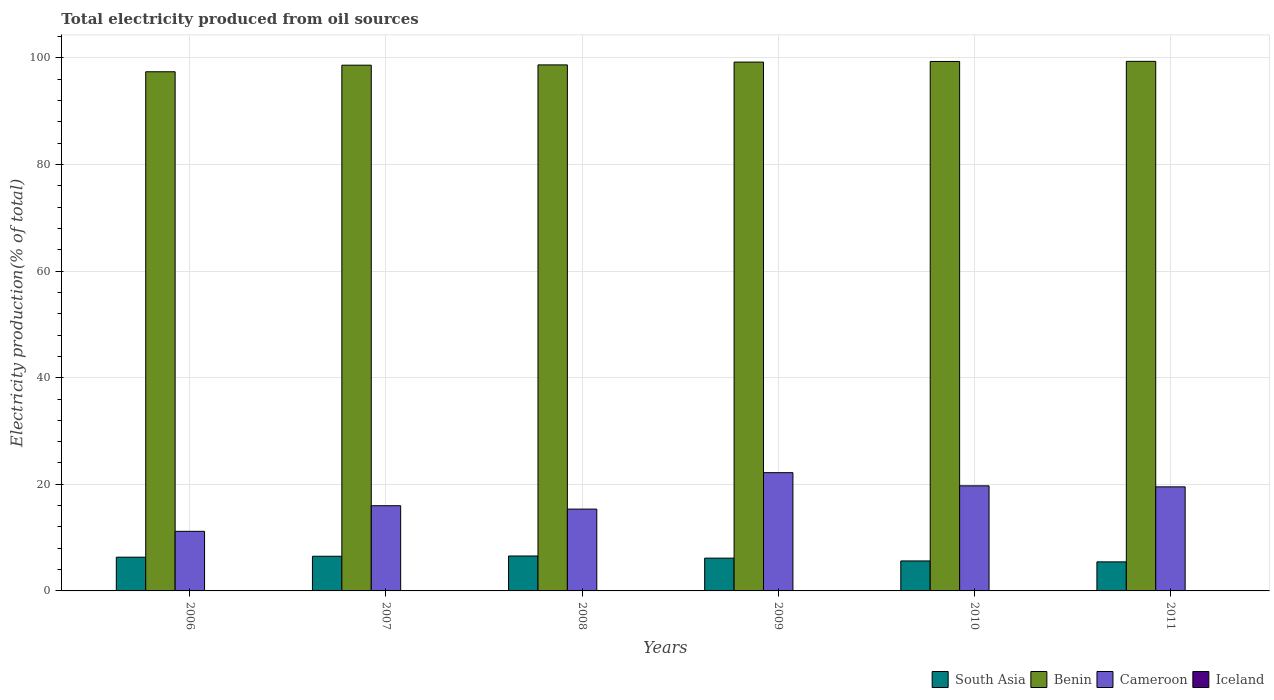How many different coloured bars are there?
Your response must be concise. 4. How many bars are there on the 6th tick from the left?
Make the answer very short. 4. What is the total electricity produced in Cameroon in 2008?
Your response must be concise. 15.35. Across all years, what is the maximum total electricity produced in Cameroon?
Give a very brief answer. 22.19. Across all years, what is the minimum total electricity produced in Cameroon?
Keep it short and to the point. 11.18. What is the total total electricity produced in Benin in the graph?
Offer a very short reply. 592.64. What is the difference between the total electricity produced in Benin in 2010 and that in 2011?
Your answer should be compact. -0.02. What is the difference between the total electricity produced in Benin in 2008 and the total electricity produced in Cameroon in 2007?
Offer a very short reply. 82.71. What is the average total electricity produced in Benin per year?
Make the answer very short. 98.77. In the year 2011, what is the difference between the total electricity produced in Iceland and total electricity produced in Cameroon?
Offer a very short reply. -19.51. What is the ratio of the total electricity produced in South Asia in 2007 to that in 2011?
Ensure brevity in your answer.  1.19. Is the total electricity produced in Iceland in 2006 less than that in 2007?
Provide a short and direct response. No. What is the difference between the highest and the second highest total electricity produced in Cameroon?
Give a very brief answer. 2.47. What is the difference between the highest and the lowest total electricity produced in Iceland?
Provide a succinct answer. 0.03. Is the sum of the total electricity produced in Cameroon in 2007 and 2010 greater than the maximum total electricity produced in Iceland across all years?
Offer a terse response. Yes. What does the 3rd bar from the left in 2008 represents?
Your answer should be very brief. Cameroon. Is it the case that in every year, the sum of the total electricity produced in South Asia and total electricity produced in Cameroon is greater than the total electricity produced in Benin?
Keep it short and to the point. No. Are all the bars in the graph horizontal?
Offer a very short reply. No. What is the difference between two consecutive major ticks on the Y-axis?
Your response must be concise. 20. Where does the legend appear in the graph?
Offer a very short reply. Bottom right. How are the legend labels stacked?
Your answer should be compact. Horizontal. What is the title of the graph?
Offer a terse response. Total electricity produced from oil sources. What is the label or title of the X-axis?
Keep it short and to the point. Years. What is the Electricity production(% of total) of South Asia in 2006?
Your answer should be compact. 6.33. What is the Electricity production(% of total) of Benin in 2006?
Your answer should be very brief. 97.4. What is the Electricity production(% of total) of Cameroon in 2006?
Give a very brief answer. 11.18. What is the Electricity production(% of total) in Iceland in 2006?
Ensure brevity in your answer.  0.04. What is the Electricity production(% of total) of South Asia in 2007?
Your answer should be compact. 6.5. What is the Electricity production(% of total) in Benin in 2007?
Ensure brevity in your answer.  98.64. What is the Electricity production(% of total) in Cameroon in 2007?
Keep it short and to the point. 15.98. What is the Electricity production(% of total) in Iceland in 2007?
Your response must be concise. 0.02. What is the Electricity production(% of total) in South Asia in 2008?
Your answer should be very brief. 6.55. What is the Electricity production(% of total) in Benin in 2008?
Provide a succinct answer. 98.69. What is the Electricity production(% of total) in Cameroon in 2008?
Offer a very short reply. 15.35. What is the Electricity production(% of total) of Iceland in 2008?
Your answer should be very brief. 0.01. What is the Electricity production(% of total) in South Asia in 2009?
Your answer should be very brief. 6.15. What is the Electricity production(% of total) in Benin in 2009?
Offer a very short reply. 99.22. What is the Electricity production(% of total) in Cameroon in 2009?
Your response must be concise. 22.19. What is the Electricity production(% of total) in Iceland in 2009?
Keep it short and to the point. 0.01. What is the Electricity production(% of total) of South Asia in 2010?
Your response must be concise. 5.63. What is the Electricity production(% of total) of Benin in 2010?
Offer a terse response. 99.33. What is the Electricity production(% of total) in Cameroon in 2010?
Keep it short and to the point. 19.72. What is the Electricity production(% of total) in Iceland in 2010?
Keep it short and to the point. 0.01. What is the Electricity production(% of total) of South Asia in 2011?
Give a very brief answer. 5.45. What is the Electricity production(% of total) of Benin in 2011?
Offer a very short reply. 99.35. What is the Electricity production(% of total) in Cameroon in 2011?
Keep it short and to the point. 19.53. What is the Electricity production(% of total) of Iceland in 2011?
Offer a terse response. 0.01. Across all years, what is the maximum Electricity production(% of total) in South Asia?
Give a very brief answer. 6.55. Across all years, what is the maximum Electricity production(% of total) of Benin?
Your answer should be very brief. 99.35. Across all years, what is the maximum Electricity production(% of total) in Cameroon?
Offer a terse response. 22.19. Across all years, what is the maximum Electricity production(% of total) of Iceland?
Your response must be concise. 0.04. Across all years, what is the minimum Electricity production(% of total) in South Asia?
Your answer should be very brief. 5.45. Across all years, what is the minimum Electricity production(% of total) in Benin?
Provide a short and direct response. 97.4. Across all years, what is the minimum Electricity production(% of total) of Cameroon?
Provide a short and direct response. 11.18. Across all years, what is the minimum Electricity production(% of total) of Iceland?
Your answer should be very brief. 0.01. What is the total Electricity production(% of total) of South Asia in the graph?
Your response must be concise. 36.62. What is the total Electricity production(% of total) in Benin in the graph?
Your response must be concise. 592.64. What is the total Electricity production(% of total) of Cameroon in the graph?
Offer a very short reply. 103.94. What is the total Electricity production(% of total) in Iceland in the graph?
Keep it short and to the point. 0.1. What is the difference between the Electricity production(% of total) of South Asia in 2006 and that in 2007?
Keep it short and to the point. -0.17. What is the difference between the Electricity production(% of total) of Benin in 2006 and that in 2007?
Offer a very short reply. -1.23. What is the difference between the Electricity production(% of total) of Cameroon in 2006 and that in 2007?
Offer a terse response. -4.8. What is the difference between the Electricity production(% of total) in Iceland in 2006 and that in 2007?
Offer a terse response. 0.02. What is the difference between the Electricity production(% of total) in South Asia in 2006 and that in 2008?
Give a very brief answer. -0.22. What is the difference between the Electricity production(% of total) of Benin in 2006 and that in 2008?
Provide a short and direct response. -1.29. What is the difference between the Electricity production(% of total) of Cameroon in 2006 and that in 2008?
Your answer should be very brief. -4.17. What is the difference between the Electricity production(% of total) of Iceland in 2006 and that in 2008?
Your answer should be very brief. 0.03. What is the difference between the Electricity production(% of total) of South Asia in 2006 and that in 2009?
Keep it short and to the point. 0.18. What is the difference between the Electricity production(% of total) in Benin in 2006 and that in 2009?
Your response must be concise. -1.82. What is the difference between the Electricity production(% of total) in Cameroon in 2006 and that in 2009?
Your answer should be compact. -11. What is the difference between the Electricity production(% of total) in Iceland in 2006 and that in 2009?
Keep it short and to the point. 0.03. What is the difference between the Electricity production(% of total) in South Asia in 2006 and that in 2010?
Provide a short and direct response. 0.7. What is the difference between the Electricity production(% of total) of Benin in 2006 and that in 2010?
Give a very brief answer. -1.93. What is the difference between the Electricity production(% of total) of Cameroon in 2006 and that in 2010?
Your answer should be very brief. -8.53. What is the difference between the Electricity production(% of total) in Iceland in 2006 and that in 2010?
Your answer should be very brief. 0.03. What is the difference between the Electricity production(% of total) in South Asia in 2006 and that in 2011?
Give a very brief answer. 0.88. What is the difference between the Electricity production(% of total) in Benin in 2006 and that in 2011?
Offer a very short reply. -1.95. What is the difference between the Electricity production(% of total) of Cameroon in 2006 and that in 2011?
Provide a succinct answer. -8.34. What is the difference between the Electricity production(% of total) in Iceland in 2006 and that in 2011?
Give a very brief answer. 0.03. What is the difference between the Electricity production(% of total) in South Asia in 2007 and that in 2008?
Provide a short and direct response. -0.05. What is the difference between the Electricity production(% of total) of Benin in 2007 and that in 2008?
Your response must be concise. -0.05. What is the difference between the Electricity production(% of total) in Cameroon in 2007 and that in 2008?
Your answer should be very brief. 0.63. What is the difference between the Electricity production(% of total) in Iceland in 2007 and that in 2008?
Ensure brevity in your answer.  0. What is the difference between the Electricity production(% of total) of South Asia in 2007 and that in 2009?
Offer a very short reply. 0.35. What is the difference between the Electricity production(% of total) in Benin in 2007 and that in 2009?
Ensure brevity in your answer.  -0.58. What is the difference between the Electricity production(% of total) in Cameroon in 2007 and that in 2009?
Your answer should be very brief. -6.2. What is the difference between the Electricity production(% of total) of Iceland in 2007 and that in 2009?
Provide a succinct answer. 0. What is the difference between the Electricity production(% of total) in South Asia in 2007 and that in 2010?
Make the answer very short. 0.88. What is the difference between the Electricity production(% of total) in Benin in 2007 and that in 2010?
Your answer should be compact. -0.7. What is the difference between the Electricity production(% of total) of Cameroon in 2007 and that in 2010?
Make the answer very short. -3.73. What is the difference between the Electricity production(% of total) in Iceland in 2007 and that in 2010?
Your response must be concise. 0.01. What is the difference between the Electricity production(% of total) in South Asia in 2007 and that in 2011?
Provide a short and direct response. 1.05. What is the difference between the Electricity production(% of total) of Benin in 2007 and that in 2011?
Your answer should be very brief. -0.72. What is the difference between the Electricity production(% of total) of Cameroon in 2007 and that in 2011?
Make the answer very short. -3.54. What is the difference between the Electricity production(% of total) in Iceland in 2007 and that in 2011?
Your response must be concise. 0.01. What is the difference between the Electricity production(% of total) in South Asia in 2008 and that in 2009?
Ensure brevity in your answer.  0.4. What is the difference between the Electricity production(% of total) of Benin in 2008 and that in 2009?
Provide a short and direct response. -0.53. What is the difference between the Electricity production(% of total) of Cameroon in 2008 and that in 2009?
Your response must be concise. -6.84. What is the difference between the Electricity production(% of total) in South Asia in 2008 and that in 2010?
Make the answer very short. 0.93. What is the difference between the Electricity production(% of total) of Benin in 2008 and that in 2010?
Your response must be concise. -0.64. What is the difference between the Electricity production(% of total) in Cameroon in 2008 and that in 2010?
Your answer should be compact. -4.37. What is the difference between the Electricity production(% of total) in Iceland in 2008 and that in 2010?
Your answer should be very brief. 0. What is the difference between the Electricity production(% of total) in South Asia in 2008 and that in 2011?
Ensure brevity in your answer.  1.1. What is the difference between the Electricity production(% of total) in Benin in 2008 and that in 2011?
Your response must be concise. -0.66. What is the difference between the Electricity production(% of total) in Cameroon in 2008 and that in 2011?
Provide a short and direct response. -4.18. What is the difference between the Electricity production(% of total) in South Asia in 2009 and that in 2010?
Your answer should be compact. 0.53. What is the difference between the Electricity production(% of total) in Benin in 2009 and that in 2010?
Your response must be concise. -0.11. What is the difference between the Electricity production(% of total) in Cameroon in 2009 and that in 2010?
Provide a succinct answer. 2.47. What is the difference between the Electricity production(% of total) in South Asia in 2009 and that in 2011?
Give a very brief answer. 0.7. What is the difference between the Electricity production(% of total) of Benin in 2009 and that in 2011?
Provide a succinct answer. -0.14. What is the difference between the Electricity production(% of total) of Cameroon in 2009 and that in 2011?
Offer a very short reply. 2.66. What is the difference between the Electricity production(% of total) in Iceland in 2009 and that in 2011?
Give a very brief answer. 0. What is the difference between the Electricity production(% of total) in South Asia in 2010 and that in 2011?
Keep it short and to the point. 0.17. What is the difference between the Electricity production(% of total) of Benin in 2010 and that in 2011?
Ensure brevity in your answer.  -0.02. What is the difference between the Electricity production(% of total) in Cameroon in 2010 and that in 2011?
Provide a short and direct response. 0.19. What is the difference between the Electricity production(% of total) in South Asia in 2006 and the Electricity production(% of total) in Benin in 2007?
Give a very brief answer. -92.31. What is the difference between the Electricity production(% of total) in South Asia in 2006 and the Electricity production(% of total) in Cameroon in 2007?
Your response must be concise. -9.65. What is the difference between the Electricity production(% of total) in South Asia in 2006 and the Electricity production(% of total) in Iceland in 2007?
Provide a short and direct response. 6.31. What is the difference between the Electricity production(% of total) of Benin in 2006 and the Electricity production(% of total) of Cameroon in 2007?
Provide a succinct answer. 81.42. What is the difference between the Electricity production(% of total) of Benin in 2006 and the Electricity production(% of total) of Iceland in 2007?
Offer a terse response. 97.39. What is the difference between the Electricity production(% of total) of Cameroon in 2006 and the Electricity production(% of total) of Iceland in 2007?
Provide a short and direct response. 11.17. What is the difference between the Electricity production(% of total) of South Asia in 2006 and the Electricity production(% of total) of Benin in 2008?
Offer a very short reply. -92.36. What is the difference between the Electricity production(% of total) in South Asia in 2006 and the Electricity production(% of total) in Cameroon in 2008?
Your answer should be very brief. -9.02. What is the difference between the Electricity production(% of total) of South Asia in 2006 and the Electricity production(% of total) of Iceland in 2008?
Ensure brevity in your answer.  6.32. What is the difference between the Electricity production(% of total) in Benin in 2006 and the Electricity production(% of total) in Cameroon in 2008?
Give a very brief answer. 82.05. What is the difference between the Electricity production(% of total) in Benin in 2006 and the Electricity production(% of total) in Iceland in 2008?
Give a very brief answer. 97.39. What is the difference between the Electricity production(% of total) of Cameroon in 2006 and the Electricity production(% of total) of Iceland in 2008?
Keep it short and to the point. 11.17. What is the difference between the Electricity production(% of total) in South Asia in 2006 and the Electricity production(% of total) in Benin in 2009?
Make the answer very short. -92.89. What is the difference between the Electricity production(% of total) in South Asia in 2006 and the Electricity production(% of total) in Cameroon in 2009?
Offer a very short reply. -15.86. What is the difference between the Electricity production(% of total) of South Asia in 2006 and the Electricity production(% of total) of Iceland in 2009?
Provide a succinct answer. 6.32. What is the difference between the Electricity production(% of total) of Benin in 2006 and the Electricity production(% of total) of Cameroon in 2009?
Give a very brief answer. 75.22. What is the difference between the Electricity production(% of total) of Benin in 2006 and the Electricity production(% of total) of Iceland in 2009?
Your answer should be compact. 97.39. What is the difference between the Electricity production(% of total) of Cameroon in 2006 and the Electricity production(% of total) of Iceland in 2009?
Provide a short and direct response. 11.17. What is the difference between the Electricity production(% of total) of South Asia in 2006 and the Electricity production(% of total) of Benin in 2010?
Your response must be concise. -93. What is the difference between the Electricity production(% of total) in South Asia in 2006 and the Electricity production(% of total) in Cameroon in 2010?
Your response must be concise. -13.38. What is the difference between the Electricity production(% of total) in South Asia in 2006 and the Electricity production(% of total) in Iceland in 2010?
Ensure brevity in your answer.  6.32. What is the difference between the Electricity production(% of total) of Benin in 2006 and the Electricity production(% of total) of Cameroon in 2010?
Make the answer very short. 77.69. What is the difference between the Electricity production(% of total) in Benin in 2006 and the Electricity production(% of total) in Iceland in 2010?
Offer a terse response. 97.39. What is the difference between the Electricity production(% of total) in Cameroon in 2006 and the Electricity production(% of total) in Iceland in 2010?
Provide a succinct answer. 11.17. What is the difference between the Electricity production(% of total) of South Asia in 2006 and the Electricity production(% of total) of Benin in 2011?
Ensure brevity in your answer.  -93.02. What is the difference between the Electricity production(% of total) in South Asia in 2006 and the Electricity production(% of total) in Cameroon in 2011?
Keep it short and to the point. -13.2. What is the difference between the Electricity production(% of total) of South Asia in 2006 and the Electricity production(% of total) of Iceland in 2011?
Provide a short and direct response. 6.32. What is the difference between the Electricity production(% of total) in Benin in 2006 and the Electricity production(% of total) in Cameroon in 2011?
Your response must be concise. 77.88. What is the difference between the Electricity production(% of total) in Benin in 2006 and the Electricity production(% of total) in Iceland in 2011?
Provide a succinct answer. 97.39. What is the difference between the Electricity production(% of total) of Cameroon in 2006 and the Electricity production(% of total) of Iceland in 2011?
Your answer should be compact. 11.17. What is the difference between the Electricity production(% of total) of South Asia in 2007 and the Electricity production(% of total) of Benin in 2008?
Your answer should be very brief. -92.19. What is the difference between the Electricity production(% of total) in South Asia in 2007 and the Electricity production(% of total) in Cameroon in 2008?
Provide a short and direct response. -8.85. What is the difference between the Electricity production(% of total) of South Asia in 2007 and the Electricity production(% of total) of Iceland in 2008?
Ensure brevity in your answer.  6.49. What is the difference between the Electricity production(% of total) in Benin in 2007 and the Electricity production(% of total) in Cameroon in 2008?
Your answer should be compact. 83.29. What is the difference between the Electricity production(% of total) in Benin in 2007 and the Electricity production(% of total) in Iceland in 2008?
Provide a short and direct response. 98.62. What is the difference between the Electricity production(% of total) of Cameroon in 2007 and the Electricity production(% of total) of Iceland in 2008?
Offer a terse response. 15.97. What is the difference between the Electricity production(% of total) of South Asia in 2007 and the Electricity production(% of total) of Benin in 2009?
Offer a terse response. -92.72. What is the difference between the Electricity production(% of total) in South Asia in 2007 and the Electricity production(% of total) in Cameroon in 2009?
Ensure brevity in your answer.  -15.68. What is the difference between the Electricity production(% of total) of South Asia in 2007 and the Electricity production(% of total) of Iceland in 2009?
Offer a very short reply. 6.49. What is the difference between the Electricity production(% of total) of Benin in 2007 and the Electricity production(% of total) of Cameroon in 2009?
Keep it short and to the point. 76.45. What is the difference between the Electricity production(% of total) of Benin in 2007 and the Electricity production(% of total) of Iceland in 2009?
Offer a very short reply. 98.62. What is the difference between the Electricity production(% of total) of Cameroon in 2007 and the Electricity production(% of total) of Iceland in 2009?
Your response must be concise. 15.97. What is the difference between the Electricity production(% of total) of South Asia in 2007 and the Electricity production(% of total) of Benin in 2010?
Provide a short and direct response. -92.83. What is the difference between the Electricity production(% of total) of South Asia in 2007 and the Electricity production(% of total) of Cameroon in 2010?
Offer a very short reply. -13.21. What is the difference between the Electricity production(% of total) in South Asia in 2007 and the Electricity production(% of total) in Iceland in 2010?
Ensure brevity in your answer.  6.49. What is the difference between the Electricity production(% of total) in Benin in 2007 and the Electricity production(% of total) in Cameroon in 2010?
Provide a short and direct response. 78.92. What is the difference between the Electricity production(% of total) of Benin in 2007 and the Electricity production(% of total) of Iceland in 2010?
Offer a very short reply. 98.62. What is the difference between the Electricity production(% of total) in Cameroon in 2007 and the Electricity production(% of total) in Iceland in 2010?
Your answer should be compact. 15.97. What is the difference between the Electricity production(% of total) of South Asia in 2007 and the Electricity production(% of total) of Benin in 2011?
Give a very brief answer. -92.85. What is the difference between the Electricity production(% of total) of South Asia in 2007 and the Electricity production(% of total) of Cameroon in 2011?
Offer a very short reply. -13.02. What is the difference between the Electricity production(% of total) of South Asia in 2007 and the Electricity production(% of total) of Iceland in 2011?
Offer a very short reply. 6.49. What is the difference between the Electricity production(% of total) in Benin in 2007 and the Electricity production(% of total) in Cameroon in 2011?
Your answer should be compact. 79.11. What is the difference between the Electricity production(% of total) of Benin in 2007 and the Electricity production(% of total) of Iceland in 2011?
Provide a succinct answer. 98.62. What is the difference between the Electricity production(% of total) of Cameroon in 2007 and the Electricity production(% of total) of Iceland in 2011?
Offer a terse response. 15.97. What is the difference between the Electricity production(% of total) of South Asia in 2008 and the Electricity production(% of total) of Benin in 2009?
Ensure brevity in your answer.  -92.66. What is the difference between the Electricity production(% of total) of South Asia in 2008 and the Electricity production(% of total) of Cameroon in 2009?
Make the answer very short. -15.63. What is the difference between the Electricity production(% of total) of South Asia in 2008 and the Electricity production(% of total) of Iceland in 2009?
Make the answer very short. 6.54. What is the difference between the Electricity production(% of total) in Benin in 2008 and the Electricity production(% of total) in Cameroon in 2009?
Make the answer very short. 76.5. What is the difference between the Electricity production(% of total) in Benin in 2008 and the Electricity production(% of total) in Iceland in 2009?
Your response must be concise. 98.68. What is the difference between the Electricity production(% of total) in Cameroon in 2008 and the Electricity production(% of total) in Iceland in 2009?
Your response must be concise. 15.34. What is the difference between the Electricity production(% of total) of South Asia in 2008 and the Electricity production(% of total) of Benin in 2010?
Keep it short and to the point. -92.78. What is the difference between the Electricity production(% of total) in South Asia in 2008 and the Electricity production(% of total) in Cameroon in 2010?
Your answer should be compact. -13.16. What is the difference between the Electricity production(% of total) of South Asia in 2008 and the Electricity production(% of total) of Iceland in 2010?
Offer a terse response. 6.54. What is the difference between the Electricity production(% of total) in Benin in 2008 and the Electricity production(% of total) in Cameroon in 2010?
Your answer should be compact. 78.97. What is the difference between the Electricity production(% of total) of Benin in 2008 and the Electricity production(% of total) of Iceland in 2010?
Your answer should be very brief. 98.68. What is the difference between the Electricity production(% of total) in Cameroon in 2008 and the Electricity production(% of total) in Iceland in 2010?
Your response must be concise. 15.34. What is the difference between the Electricity production(% of total) of South Asia in 2008 and the Electricity production(% of total) of Benin in 2011?
Your answer should be compact. -92.8. What is the difference between the Electricity production(% of total) of South Asia in 2008 and the Electricity production(% of total) of Cameroon in 2011?
Keep it short and to the point. -12.97. What is the difference between the Electricity production(% of total) in South Asia in 2008 and the Electricity production(% of total) in Iceland in 2011?
Your answer should be compact. 6.54. What is the difference between the Electricity production(% of total) in Benin in 2008 and the Electricity production(% of total) in Cameroon in 2011?
Make the answer very short. 79.16. What is the difference between the Electricity production(% of total) of Benin in 2008 and the Electricity production(% of total) of Iceland in 2011?
Offer a very short reply. 98.68. What is the difference between the Electricity production(% of total) in Cameroon in 2008 and the Electricity production(% of total) in Iceland in 2011?
Give a very brief answer. 15.34. What is the difference between the Electricity production(% of total) in South Asia in 2009 and the Electricity production(% of total) in Benin in 2010?
Offer a terse response. -93.18. What is the difference between the Electricity production(% of total) in South Asia in 2009 and the Electricity production(% of total) in Cameroon in 2010?
Make the answer very short. -13.56. What is the difference between the Electricity production(% of total) in South Asia in 2009 and the Electricity production(% of total) in Iceland in 2010?
Provide a succinct answer. 6.14. What is the difference between the Electricity production(% of total) in Benin in 2009 and the Electricity production(% of total) in Cameroon in 2010?
Provide a succinct answer. 79.5. What is the difference between the Electricity production(% of total) in Benin in 2009 and the Electricity production(% of total) in Iceland in 2010?
Ensure brevity in your answer.  99.21. What is the difference between the Electricity production(% of total) of Cameroon in 2009 and the Electricity production(% of total) of Iceland in 2010?
Offer a terse response. 22.17. What is the difference between the Electricity production(% of total) in South Asia in 2009 and the Electricity production(% of total) in Benin in 2011?
Ensure brevity in your answer.  -93.2. What is the difference between the Electricity production(% of total) of South Asia in 2009 and the Electricity production(% of total) of Cameroon in 2011?
Provide a short and direct response. -13.37. What is the difference between the Electricity production(% of total) in South Asia in 2009 and the Electricity production(% of total) in Iceland in 2011?
Your answer should be very brief. 6.14. What is the difference between the Electricity production(% of total) in Benin in 2009 and the Electricity production(% of total) in Cameroon in 2011?
Provide a short and direct response. 79.69. What is the difference between the Electricity production(% of total) in Benin in 2009 and the Electricity production(% of total) in Iceland in 2011?
Ensure brevity in your answer.  99.21. What is the difference between the Electricity production(% of total) in Cameroon in 2009 and the Electricity production(% of total) in Iceland in 2011?
Give a very brief answer. 22.17. What is the difference between the Electricity production(% of total) of South Asia in 2010 and the Electricity production(% of total) of Benin in 2011?
Your answer should be compact. -93.73. What is the difference between the Electricity production(% of total) in South Asia in 2010 and the Electricity production(% of total) in Iceland in 2011?
Your response must be concise. 5.61. What is the difference between the Electricity production(% of total) of Benin in 2010 and the Electricity production(% of total) of Cameroon in 2011?
Provide a succinct answer. 79.81. What is the difference between the Electricity production(% of total) in Benin in 2010 and the Electricity production(% of total) in Iceland in 2011?
Provide a succinct answer. 99.32. What is the difference between the Electricity production(% of total) of Cameroon in 2010 and the Electricity production(% of total) of Iceland in 2011?
Your answer should be very brief. 19.7. What is the average Electricity production(% of total) of South Asia per year?
Your answer should be compact. 6.1. What is the average Electricity production(% of total) in Benin per year?
Make the answer very short. 98.77. What is the average Electricity production(% of total) in Cameroon per year?
Make the answer very short. 17.32. What is the average Electricity production(% of total) in Iceland per year?
Give a very brief answer. 0.02. In the year 2006, what is the difference between the Electricity production(% of total) in South Asia and Electricity production(% of total) in Benin?
Offer a very short reply. -91.07. In the year 2006, what is the difference between the Electricity production(% of total) in South Asia and Electricity production(% of total) in Cameroon?
Keep it short and to the point. -4.85. In the year 2006, what is the difference between the Electricity production(% of total) in South Asia and Electricity production(% of total) in Iceland?
Ensure brevity in your answer.  6.29. In the year 2006, what is the difference between the Electricity production(% of total) of Benin and Electricity production(% of total) of Cameroon?
Offer a very short reply. 86.22. In the year 2006, what is the difference between the Electricity production(% of total) of Benin and Electricity production(% of total) of Iceland?
Your answer should be very brief. 97.36. In the year 2006, what is the difference between the Electricity production(% of total) in Cameroon and Electricity production(% of total) in Iceland?
Your response must be concise. 11.14. In the year 2007, what is the difference between the Electricity production(% of total) of South Asia and Electricity production(% of total) of Benin?
Provide a succinct answer. -92.13. In the year 2007, what is the difference between the Electricity production(% of total) of South Asia and Electricity production(% of total) of Cameroon?
Give a very brief answer. -9.48. In the year 2007, what is the difference between the Electricity production(% of total) in South Asia and Electricity production(% of total) in Iceland?
Offer a very short reply. 6.49. In the year 2007, what is the difference between the Electricity production(% of total) in Benin and Electricity production(% of total) in Cameroon?
Ensure brevity in your answer.  82.65. In the year 2007, what is the difference between the Electricity production(% of total) of Benin and Electricity production(% of total) of Iceland?
Offer a terse response. 98.62. In the year 2007, what is the difference between the Electricity production(% of total) in Cameroon and Electricity production(% of total) in Iceland?
Make the answer very short. 15.97. In the year 2008, what is the difference between the Electricity production(% of total) in South Asia and Electricity production(% of total) in Benin?
Provide a succinct answer. -92.14. In the year 2008, what is the difference between the Electricity production(% of total) in South Asia and Electricity production(% of total) in Cameroon?
Your answer should be very brief. -8.8. In the year 2008, what is the difference between the Electricity production(% of total) in South Asia and Electricity production(% of total) in Iceland?
Keep it short and to the point. 6.54. In the year 2008, what is the difference between the Electricity production(% of total) of Benin and Electricity production(% of total) of Cameroon?
Give a very brief answer. 83.34. In the year 2008, what is the difference between the Electricity production(% of total) of Benin and Electricity production(% of total) of Iceland?
Keep it short and to the point. 98.68. In the year 2008, what is the difference between the Electricity production(% of total) in Cameroon and Electricity production(% of total) in Iceland?
Offer a terse response. 15.34. In the year 2009, what is the difference between the Electricity production(% of total) of South Asia and Electricity production(% of total) of Benin?
Your answer should be very brief. -93.07. In the year 2009, what is the difference between the Electricity production(% of total) in South Asia and Electricity production(% of total) in Cameroon?
Provide a short and direct response. -16.03. In the year 2009, what is the difference between the Electricity production(% of total) of South Asia and Electricity production(% of total) of Iceland?
Give a very brief answer. 6.14. In the year 2009, what is the difference between the Electricity production(% of total) of Benin and Electricity production(% of total) of Cameroon?
Your answer should be compact. 77.03. In the year 2009, what is the difference between the Electricity production(% of total) of Benin and Electricity production(% of total) of Iceland?
Offer a terse response. 99.21. In the year 2009, what is the difference between the Electricity production(% of total) of Cameroon and Electricity production(% of total) of Iceland?
Offer a terse response. 22.17. In the year 2010, what is the difference between the Electricity production(% of total) in South Asia and Electricity production(% of total) in Benin?
Keep it short and to the point. -93.71. In the year 2010, what is the difference between the Electricity production(% of total) of South Asia and Electricity production(% of total) of Cameroon?
Offer a very short reply. -14.09. In the year 2010, what is the difference between the Electricity production(% of total) in South Asia and Electricity production(% of total) in Iceland?
Offer a terse response. 5.61. In the year 2010, what is the difference between the Electricity production(% of total) in Benin and Electricity production(% of total) in Cameroon?
Keep it short and to the point. 79.62. In the year 2010, what is the difference between the Electricity production(% of total) in Benin and Electricity production(% of total) in Iceland?
Offer a very short reply. 99.32. In the year 2010, what is the difference between the Electricity production(% of total) of Cameroon and Electricity production(% of total) of Iceland?
Make the answer very short. 19.7. In the year 2011, what is the difference between the Electricity production(% of total) in South Asia and Electricity production(% of total) in Benin?
Your answer should be very brief. -93.9. In the year 2011, what is the difference between the Electricity production(% of total) in South Asia and Electricity production(% of total) in Cameroon?
Keep it short and to the point. -14.07. In the year 2011, what is the difference between the Electricity production(% of total) of South Asia and Electricity production(% of total) of Iceland?
Your answer should be compact. 5.44. In the year 2011, what is the difference between the Electricity production(% of total) in Benin and Electricity production(% of total) in Cameroon?
Your answer should be very brief. 79.83. In the year 2011, what is the difference between the Electricity production(% of total) of Benin and Electricity production(% of total) of Iceland?
Provide a succinct answer. 99.34. In the year 2011, what is the difference between the Electricity production(% of total) in Cameroon and Electricity production(% of total) in Iceland?
Your response must be concise. 19.51. What is the ratio of the Electricity production(% of total) in South Asia in 2006 to that in 2007?
Your response must be concise. 0.97. What is the ratio of the Electricity production(% of total) in Benin in 2006 to that in 2007?
Offer a terse response. 0.99. What is the ratio of the Electricity production(% of total) of Cameroon in 2006 to that in 2007?
Your answer should be very brief. 0.7. What is the ratio of the Electricity production(% of total) in Iceland in 2006 to that in 2007?
Give a very brief answer. 2.41. What is the ratio of the Electricity production(% of total) in South Asia in 2006 to that in 2008?
Offer a very short reply. 0.97. What is the ratio of the Electricity production(% of total) of Cameroon in 2006 to that in 2008?
Provide a short and direct response. 0.73. What is the ratio of the Electricity production(% of total) of Iceland in 2006 to that in 2008?
Ensure brevity in your answer.  3.32. What is the ratio of the Electricity production(% of total) in South Asia in 2006 to that in 2009?
Make the answer very short. 1.03. What is the ratio of the Electricity production(% of total) in Benin in 2006 to that in 2009?
Keep it short and to the point. 0.98. What is the ratio of the Electricity production(% of total) in Cameroon in 2006 to that in 2009?
Give a very brief answer. 0.5. What is the ratio of the Electricity production(% of total) in Iceland in 2006 to that in 2009?
Your response must be concise. 3.39. What is the ratio of the Electricity production(% of total) of South Asia in 2006 to that in 2010?
Offer a terse response. 1.13. What is the ratio of the Electricity production(% of total) in Benin in 2006 to that in 2010?
Ensure brevity in your answer.  0.98. What is the ratio of the Electricity production(% of total) in Cameroon in 2006 to that in 2010?
Your response must be concise. 0.57. What is the ratio of the Electricity production(% of total) in Iceland in 2006 to that in 2010?
Offer a terse response. 3.44. What is the ratio of the Electricity production(% of total) of South Asia in 2006 to that in 2011?
Offer a very short reply. 1.16. What is the ratio of the Electricity production(% of total) of Benin in 2006 to that in 2011?
Your answer should be compact. 0.98. What is the ratio of the Electricity production(% of total) in Cameroon in 2006 to that in 2011?
Offer a very short reply. 0.57. What is the ratio of the Electricity production(% of total) of Iceland in 2006 to that in 2011?
Your response must be concise. 3.47. What is the ratio of the Electricity production(% of total) in Benin in 2007 to that in 2008?
Your answer should be compact. 1. What is the ratio of the Electricity production(% of total) in Cameroon in 2007 to that in 2008?
Offer a very short reply. 1.04. What is the ratio of the Electricity production(% of total) of Iceland in 2007 to that in 2008?
Provide a succinct answer. 1.37. What is the ratio of the Electricity production(% of total) in South Asia in 2007 to that in 2009?
Offer a very short reply. 1.06. What is the ratio of the Electricity production(% of total) in Cameroon in 2007 to that in 2009?
Give a very brief answer. 0.72. What is the ratio of the Electricity production(% of total) of Iceland in 2007 to that in 2009?
Your response must be concise. 1.41. What is the ratio of the Electricity production(% of total) of South Asia in 2007 to that in 2010?
Provide a succinct answer. 1.16. What is the ratio of the Electricity production(% of total) in Benin in 2007 to that in 2010?
Offer a terse response. 0.99. What is the ratio of the Electricity production(% of total) of Cameroon in 2007 to that in 2010?
Give a very brief answer. 0.81. What is the ratio of the Electricity production(% of total) in Iceland in 2007 to that in 2010?
Provide a short and direct response. 1.42. What is the ratio of the Electricity production(% of total) of South Asia in 2007 to that in 2011?
Provide a short and direct response. 1.19. What is the ratio of the Electricity production(% of total) of Cameroon in 2007 to that in 2011?
Make the answer very short. 0.82. What is the ratio of the Electricity production(% of total) in Iceland in 2007 to that in 2011?
Make the answer very short. 1.44. What is the ratio of the Electricity production(% of total) in South Asia in 2008 to that in 2009?
Offer a very short reply. 1.07. What is the ratio of the Electricity production(% of total) in Benin in 2008 to that in 2009?
Your answer should be very brief. 0.99. What is the ratio of the Electricity production(% of total) in Cameroon in 2008 to that in 2009?
Your answer should be very brief. 0.69. What is the ratio of the Electricity production(% of total) in Iceland in 2008 to that in 2009?
Keep it short and to the point. 1.02. What is the ratio of the Electricity production(% of total) of South Asia in 2008 to that in 2010?
Offer a very short reply. 1.16. What is the ratio of the Electricity production(% of total) in Benin in 2008 to that in 2010?
Your response must be concise. 0.99. What is the ratio of the Electricity production(% of total) of Cameroon in 2008 to that in 2010?
Keep it short and to the point. 0.78. What is the ratio of the Electricity production(% of total) of Iceland in 2008 to that in 2010?
Offer a very short reply. 1.04. What is the ratio of the Electricity production(% of total) of South Asia in 2008 to that in 2011?
Offer a terse response. 1.2. What is the ratio of the Electricity production(% of total) in Benin in 2008 to that in 2011?
Provide a succinct answer. 0.99. What is the ratio of the Electricity production(% of total) in Cameroon in 2008 to that in 2011?
Give a very brief answer. 0.79. What is the ratio of the Electricity production(% of total) of Iceland in 2008 to that in 2011?
Offer a terse response. 1.05. What is the ratio of the Electricity production(% of total) of South Asia in 2009 to that in 2010?
Offer a very short reply. 1.09. What is the ratio of the Electricity production(% of total) of Benin in 2009 to that in 2010?
Offer a terse response. 1. What is the ratio of the Electricity production(% of total) in Cameroon in 2009 to that in 2010?
Your response must be concise. 1.13. What is the ratio of the Electricity production(% of total) in Iceland in 2009 to that in 2010?
Make the answer very short. 1.01. What is the ratio of the Electricity production(% of total) of South Asia in 2009 to that in 2011?
Ensure brevity in your answer.  1.13. What is the ratio of the Electricity production(% of total) of Cameroon in 2009 to that in 2011?
Give a very brief answer. 1.14. What is the ratio of the Electricity production(% of total) in Iceland in 2009 to that in 2011?
Give a very brief answer. 1.02. What is the ratio of the Electricity production(% of total) in South Asia in 2010 to that in 2011?
Offer a very short reply. 1.03. What is the ratio of the Electricity production(% of total) in Benin in 2010 to that in 2011?
Your answer should be very brief. 1. What is the ratio of the Electricity production(% of total) of Cameroon in 2010 to that in 2011?
Your answer should be compact. 1.01. What is the ratio of the Electricity production(% of total) of Iceland in 2010 to that in 2011?
Ensure brevity in your answer.  1.01. What is the difference between the highest and the second highest Electricity production(% of total) of South Asia?
Ensure brevity in your answer.  0.05. What is the difference between the highest and the second highest Electricity production(% of total) of Benin?
Provide a short and direct response. 0.02. What is the difference between the highest and the second highest Electricity production(% of total) in Cameroon?
Your answer should be compact. 2.47. What is the difference between the highest and the second highest Electricity production(% of total) in Iceland?
Offer a terse response. 0.02. What is the difference between the highest and the lowest Electricity production(% of total) in South Asia?
Give a very brief answer. 1.1. What is the difference between the highest and the lowest Electricity production(% of total) in Benin?
Your answer should be very brief. 1.95. What is the difference between the highest and the lowest Electricity production(% of total) in Cameroon?
Provide a short and direct response. 11. What is the difference between the highest and the lowest Electricity production(% of total) of Iceland?
Keep it short and to the point. 0.03. 